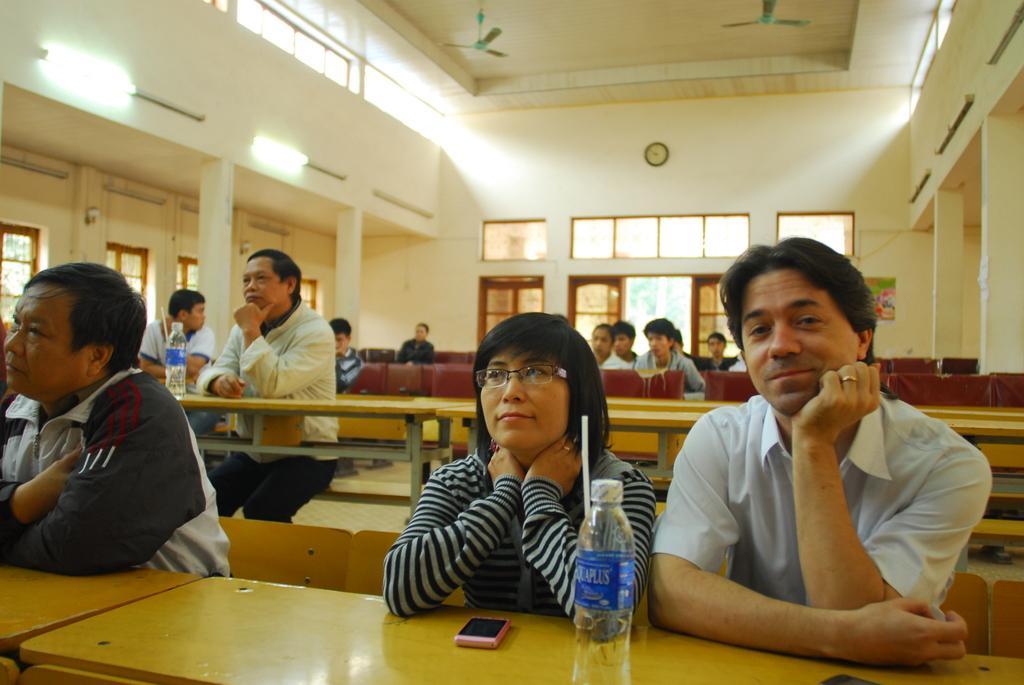Could you give a brief overview of what you see in this image? Here we can see few persons are sitting on the benches. There are bottles and mobiles on the tables. Here we can see pillars, lights, glasses, fans, and a clock. In the background we can see wall. 